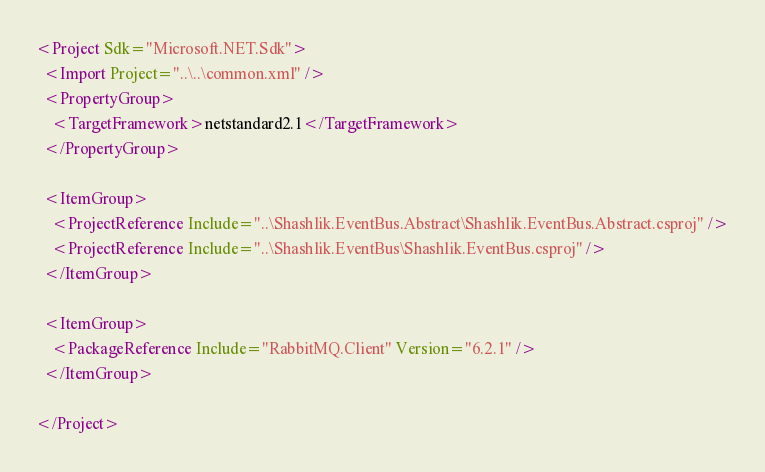<code> <loc_0><loc_0><loc_500><loc_500><_XML_><Project Sdk="Microsoft.NET.Sdk">
  <Import Project="..\..\common.xml" />
  <PropertyGroup>
    <TargetFramework>netstandard2.1</TargetFramework>
  </PropertyGroup>

  <ItemGroup>
    <ProjectReference Include="..\Shashlik.EventBus.Abstract\Shashlik.EventBus.Abstract.csproj" />
    <ProjectReference Include="..\Shashlik.EventBus\Shashlik.EventBus.csproj" />
  </ItemGroup>

  <ItemGroup>
    <PackageReference Include="RabbitMQ.Client" Version="6.2.1" />
  </ItemGroup>

</Project>
</code> 